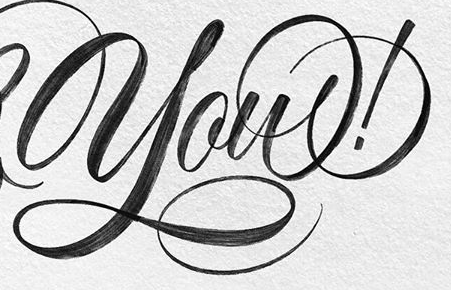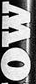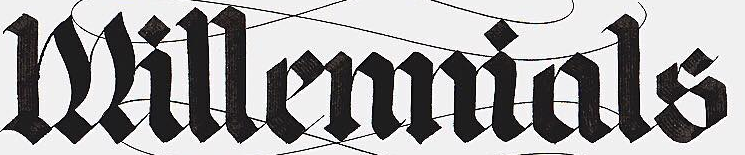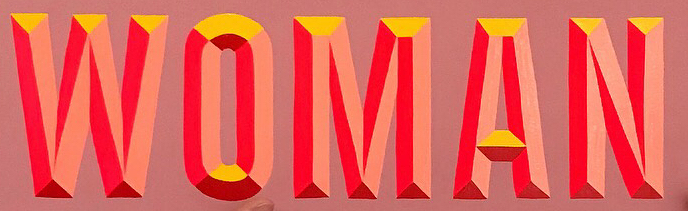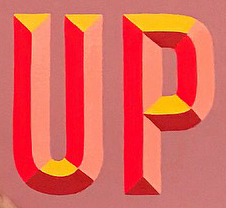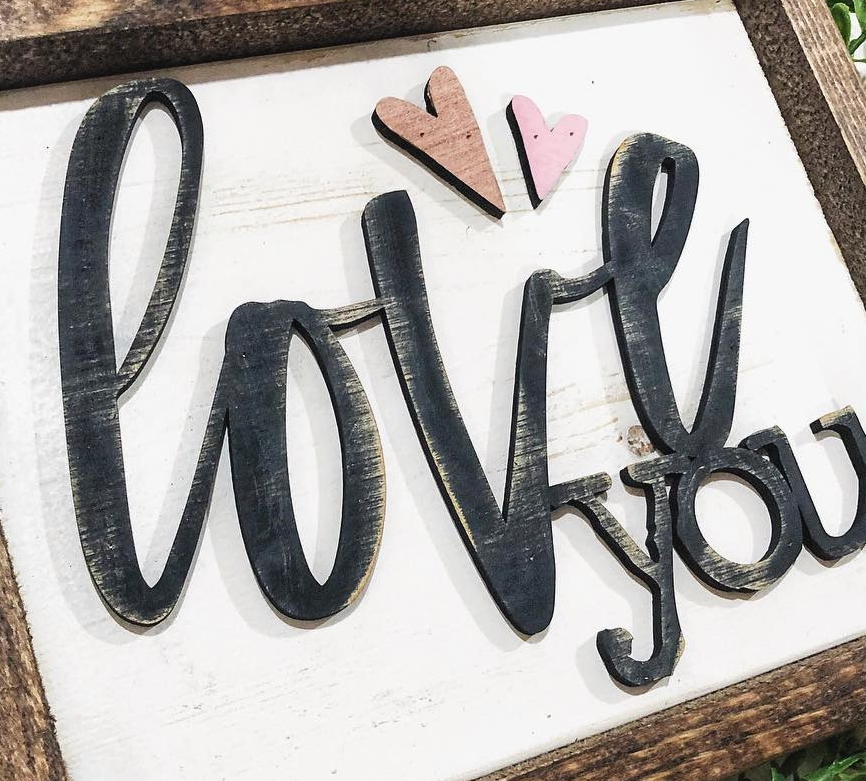What text is displayed in these images sequentially, separated by a semicolon? you!; MO; Millemmials; WOMAN; UP; love 